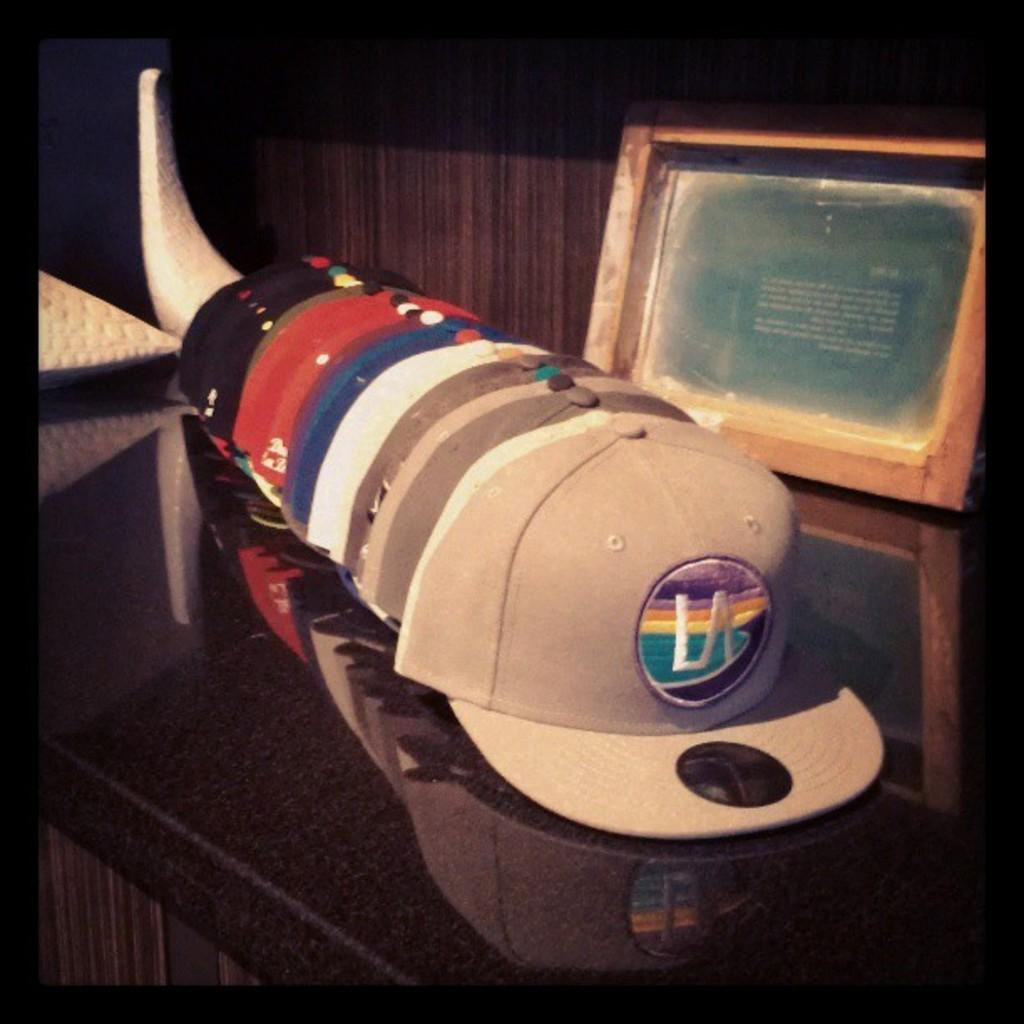What type of objects are present in the image? There are caps in the image. Where are the caps located? The caps are on a table in the image. What else can be seen on the table? There is a photo frame on the table in the image. What is visible in the background of the image? The background of the image appears to be a wall. What type of pot is being used for the action in the image? There is no pot or action present in the image. How many teeth can be seen in the image? There are no teeth visible in the image. 